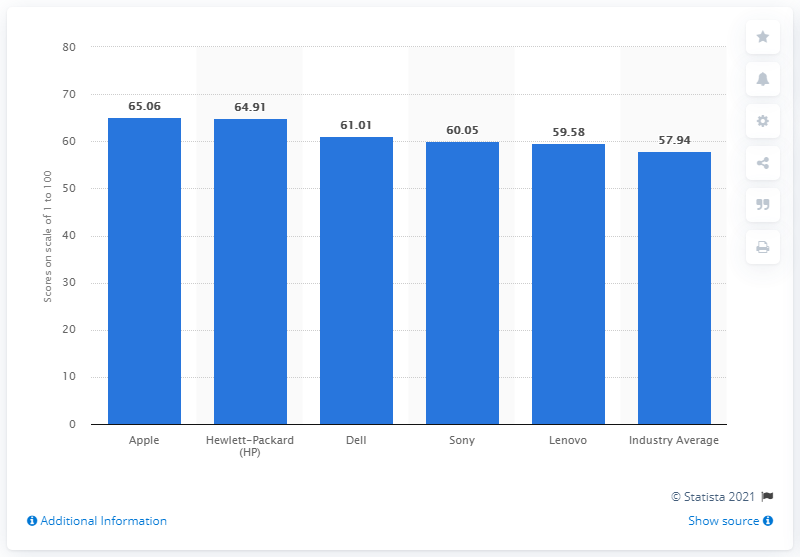List a handful of essential elements in this visual. According to the information provided, Hewlett-Packard achieved a score of 65.06 out of 100. 